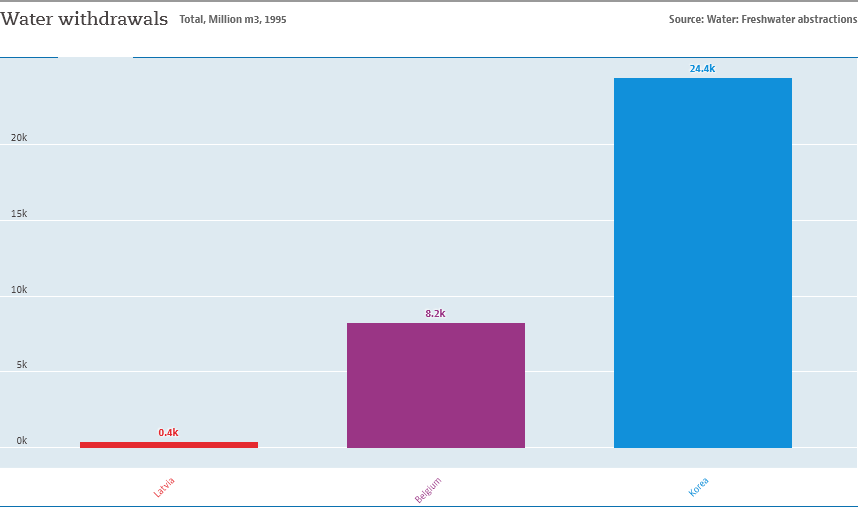Specify some key components in this picture. The difference between the smallest and second smallest value of a bar is not 1/3 the value of the largest bar. There are 3 bars in the graph. 